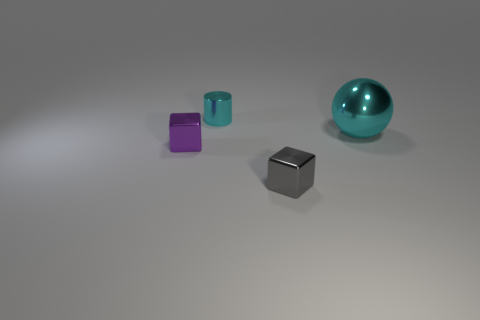There is a tiny shiny thing behind the purple cube; what number of spheres are to the right of it?
Keep it short and to the point. 1. What material is the small thing that is on the right side of the purple metal object and in front of the shiny cylinder?
Your response must be concise. Metal. The gray metal thing that is the same size as the cylinder is what shape?
Ensure brevity in your answer.  Cube. The shiny object left of the cyan shiny thing on the left side of the cyan metal object that is in front of the cyan shiny cylinder is what color?
Provide a succinct answer. Purple. What number of things are either cyan objects behind the ball or cubes?
Offer a terse response. 3. What is the material of the gray object that is the same size as the purple block?
Keep it short and to the point. Metal. The metal sphere is what color?
Offer a terse response. Cyan. What number of big objects are either purple metal blocks or gray metal objects?
Your response must be concise. 0. There is a thing that is the same color as the large sphere; what is it made of?
Keep it short and to the point. Metal. Is the object that is behind the big cyan sphere made of the same material as the large sphere on the right side of the gray shiny cube?
Provide a short and direct response. Yes. 